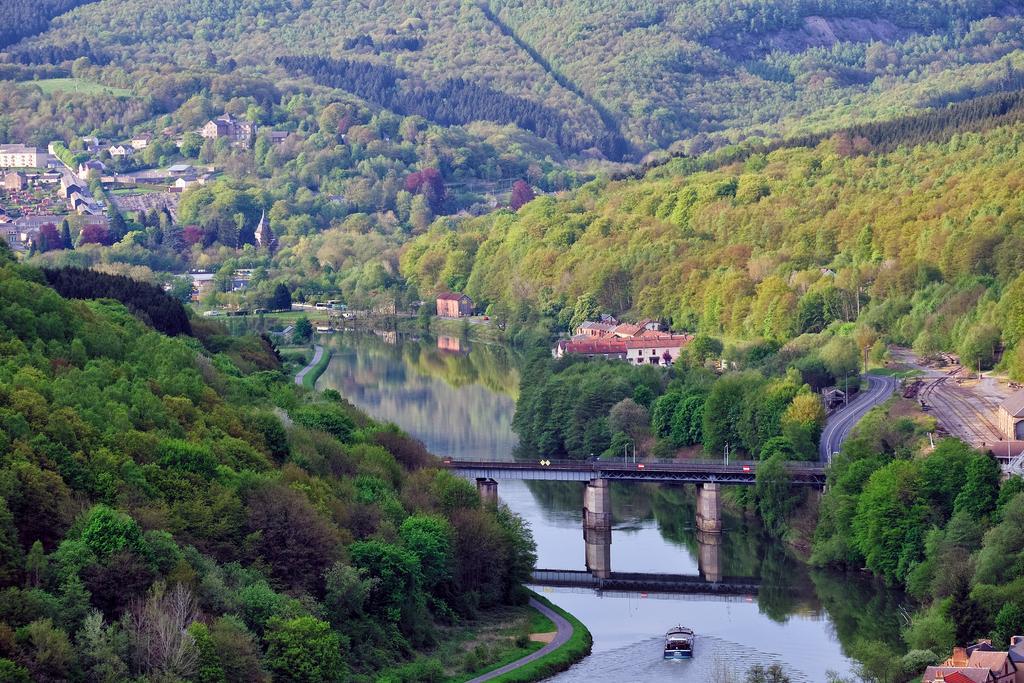Can you describe this image briefly? This picture might be taken from outside of the city and it is sunny. In this image, on the left side, we can see some trees, plants and few houses. On the right side, we can see some plants, houses, roads. In the middle of the image, we can see a bridge and a boat droning on the water. In the background, we can see some trees, plants houses. 